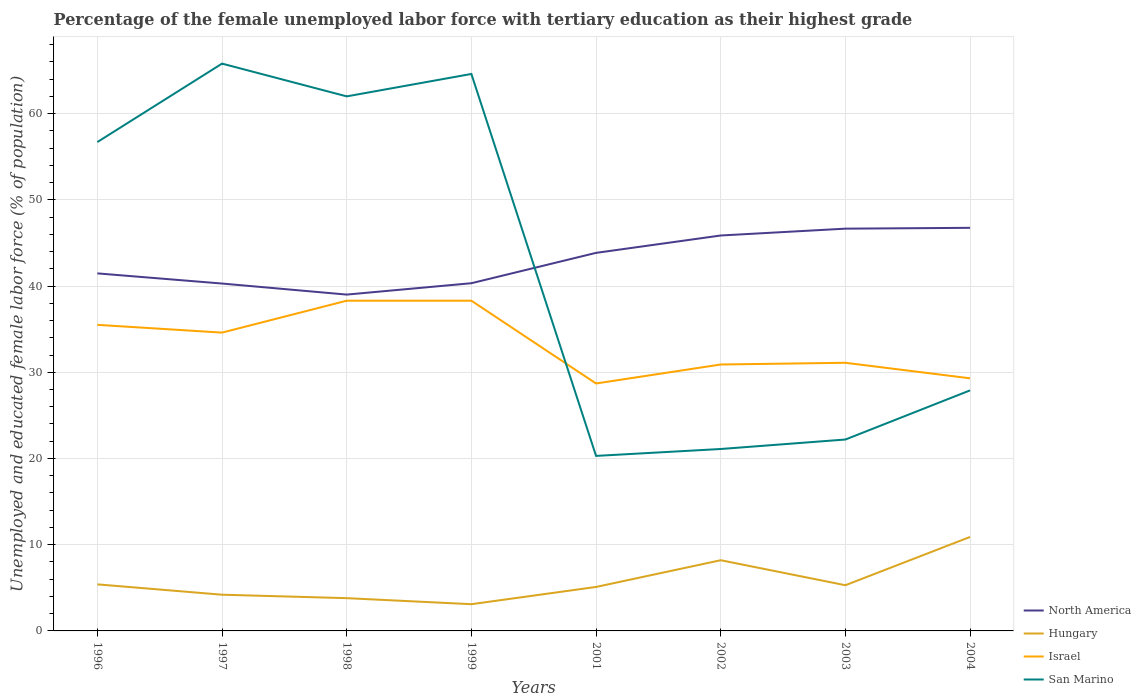Is the number of lines equal to the number of legend labels?
Provide a short and direct response. Yes. Across all years, what is the maximum percentage of the unemployed female labor force with tertiary education in San Marino?
Your answer should be very brief. 20.3. In which year was the percentage of the unemployed female labor force with tertiary education in Israel maximum?
Keep it short and to the point. 2001. What is the total percentage of the unemployed female labor force with tertiary education in San Marino in the graph?
Keep it short and to the point. 1.2. What is the difference between the highest and the second highest percentage of the unemployed female labor force with tertiary education in North America?
Make the answer very short. 7.74. Is the percentage of the unemployed female labor force with tertiary education in San Marino strictly greater than the percentage of the unemployed female labor force with tertiary education in Hungary over the years?
Your answer should be very brief. No. What is the difference between two consecutive major ticks on the Y-axis?
Offer a very short reply. 10. How are the legend labels stacked?
Offer a terse response. Vertical. What is the title of the graph?
Provide a short and direct response. Percentage of the female unemployed labor force with tertiary education as their highest grade. What is the label or title of the X-axis?
Provide a short and direct response. Years. What is the label or title of the Y-axis?
Provide a succinct answer. Unemployed and educated female labor force (% of population). What is the Unemployed and educated female labor force (% of population) in North America in 1996?
Give a very brief answer. 41.47. What is the Unemployed and educated female labor force (% of population) in Hungary in 1996?
Offer a terse response. 5.4. What is the Unemployed and educated female labor force (% of population) of Israel in 1996?
Keep it short and to the point. 35.5. What is the Unemployed and educated female labor force (% of population) in San Marino in 1996?
Provide a succinct answer. 56.7. What is the Unemployed and educated female labor force (% of population) of North America in 1997?
Your answer should be compact. 40.29. What is the Unemployed and educated female labor force (% of population) in Hungary in 1997?
Your answer should be compact. 4.2. What is the Unemployed and educated female labor force (% of population) of Israel in 1997?
Make the answer very short. 34.6. What is the Unemployed and educated female labor force (% of population) of San Marino in 1997?
Your answer should be very brief. 65.8. What is the Unemployed and educated female labor force (% of population) in North America in 1998?
Provide a succinct answer. 39.01. What is the Unemployed and educated female labor force (% of population) in Hungary in 1998?
Provide a short and direct response. 3.8. What is the Unemployed and educated female labor force (% of population) of Israel in 1998?
Your response must be concise. 38.3. What is the Unemployed and educated female labor force (% of population) of North America in 1999?
Keep it short and to the point. 40.33. What is the Unemployed and educated female labor force (% of population) in Hungary in 1999?
Offer a terse response. 3.1. What is the Unemployed and educated female labor force (% of population) in Israel in 1999?
Ensure brevity in your answer.  38.3. What is the Unemployed and educated female labor force (% of population) of San Marino in 1999?
Make the answer very short. 64.6. What is the Unemployed and educated female labor force (% of population) in North America in 2001?
Give a very brief answer. 43.85. What is the Unemployed and educated female labor force (% of population) in Hungary in 2001?
Your answer should be compact. 5.1. What is the Unemployed and educated female labor force (% of population) in Israel in 2001?
Ensure brevity in your answer.  28.7. What is the Unemployed and educated female labor force (% of population) in San Marino in 2001?
Your answer should be very brief. 20.3. What is the Unemployed and educated female labor force (% of population) in North America in 2002?
Provide a short and direct response. 45.86. What is the Unemployed and educated female labor force (% of population) in Hungary in 2002?
Keep it short and to the point. 8.2. What is the Unemployed and educated female labor force (% of population) in Israel in 2002?
Your answer should be compact. 30.9. What is the Unemployed and educated female labor force (% of population) of San Marino in 2002?
Your answer should be very brief. 21.1. What is the Unemployed and educated female labor force (% of population) of North America in 2003?
Offer a terse response. 46.66. What is the Unemployed and educated female labor force (% of population) in Hungary in 2003?
Give a very brief answer. 5.3. What is the Unemployed and educated female labor force (% of population) of Israel in 2003?
Give a very brief answer. 31.1. What is the Unemployed and educated female labor force (% of population) in San Marino in 2003?
Your answer should be very brief. 22.2. What is the Unemployed and educated female labor force (% of population) of North America in 2004?
Ensure brevity in your answer.  46.75. What is the Unemployed and educated female labor force (% of population) in Hungary in 2004?
Offer a terse response. 10.9. What is the Unemployed and educated female labor force (% of population) in Israel in 2004?
Offer a terse response. 29.3. What is the Unemployed and educated female labor force (% of population) of San Marino in 2004?
Offer a terse response. 27.9. Across all years, what is the maximum Unemployed and educated female labor force (% of population) in North America?
Your response must be concise. 46.75. Across all years, what is the maximum Unemployed and educated female labor force (% of population) of Hungary?
Provide a short and direct response. 10.9. Across all years, what is the maximum Unemployed and educated female labor force (% of population) in Israel?
Provide a succinct answer. 38.3. Across all years, what is the maximum Unemployed and educated female labor force (% of population) in San Marino?
Your answer should be compact. 65.8. Across all years, what is the minimum Unemployed and educated female labor force (% of population) in North America?
Make the answer very short. 39.01. Across all years, what is the minimum Unemployed and educated female labor force (% of population) in Hungary?
Your answer should be compact. 3.1. Across all years, what is the minimum Unemployed and educated female labor force (% of population) of Israel?
Provide a short and direct response. 28.7. Across all years, what is the minimum Unemployed and educated female labor force (% of population) of San Marino?
Your answer should be very brief. 20.3. What is the total Unemployed and educated female labor force (% of population) of North America in the graph?
Your response must be concise. 344.22. What is the total Unemployed and educated female labor force (% of population) in Hungary in the graph?
Your response must be concise. 46. What is the total Unemployed and educated female labor force (% of population) in Israel in the graph?
Keep it short and to the point. 266.7. What is the total Unemployed and educated female labor force (% of population) of San Marino in the graph?
Your response must be concise. 340.6. What is the difference between the Unemployed and educated female labor force (% of population) of North America in 1996 and that in 1997?
Give a very brief answer. 1.18. What is the difference between the Unemployed and educated female labor force (% of population) in San Marino in 1996 and that in 1997?
Give a very brief answer. -9.1. What is the difference between the Unemployed and educated female labor force (% of population) of North America in 1996 and that in 1998?
Offer a terse response. 2.46. What is the difference between the Unemployed and educated female labor force (% of population) of Israel in 1996 and that in 1998?
Your response must be concise. -2.8. What is the difference between the Unemployed and educated female labor force (% of population) in North America in 1996 and that in 1999?
Give a very brief answer. 1.14. What is the difference between the Unemployed and educated female labor force (% of population) in Hungary in 1996 and that in 1999?
Your response must be concise. 2.3. What is the difference between the Unemployed and educated female labor force (% of population) of Israel in 1996 and that in 1999?
Offer a terse response. -2.8. What is the difference between the Unemployed and educated female labor force (% of population) in San Marino in 1996 and that in 1999?
Ensure brevity in your answer.  -7.9. What is the difference between the Unemployed and educated female labor force (% of population) of North America in 1996 and that in 2001?
Your response must be concise. -2.38. What is the difference between the Unemployed and educated female labor force (% of population) in Hungary in 1996 and that in 2001?
Provide a succinct answer. 0.3. What is the difference between the Unemployed and educated female labor force (% of population) in Israel in 1996 and that in 2001?
Your answer should be compact. 6.8. What is the difference between the Unemployed and educated female labor force (% of population) of San Marino in 1996 and that in 2001?
Ensure brevity in your answer.  36.4. What is the difference between the Unemployed and educated female labor force (% of population) of North America in 1996 and that in 2002?
Your response must be concise. -4.39. What is the difference between the Unemployed and educated female labor force (% of population) in Hungary in 1996 and that in 2002?
Offer a very short reply. -2.8. What is the difference between the Unemployed and educated female labor force (% of population) of San Marino in 1996 and that in 2002?
Offer a very short reply. 35.6. What is the difference between the Unemployed and educated female labor force (% of population) of North America in 1996 and that in 2003?
Make the answer very short. -5.19. What is the difference between the Unemployed and educated female labor force (% of population) in Hungary in 1996 and that in 2003?
Your response must be concise. 0.1. What is the difference between the Unemployed and educated female labor force (% of population) of San Marino in 1996 and that in 2003?
Provide a short and direct response. 34.5. What is the difference between the Unemployed and educated female labor force (% of population) of North America in 1996 and that in 2004?
Ensure brevity in your answer.  -5.28. What is the difference between the Unemployed and educated female labor force (% of population) in Israel in 1996 and that in 2004?
Your answer should be compact. 6.2. What is the difference between the Unemployed and educated female labor force (% of population) in San Marino in 1996 and that in 2004?
Give a very brief answer. 28.8. What is the difference between the Unemployed and educated female labor force (% of population) in North America in 1997 and that in 1998?
Your answer should be compact. 1.28. What is the difference between the Unemployed and educated female labor force (% of population) of Israel in 1997 and that in 1998?
Ensure brevity in your answer.  -3.7. What is the difference between the Unemployed and educated female labor force (% of population) of San Marino in 1997 and that in 1998?
Offer a terse response. 3.8. What is the difference between the Unemployed and educated female labor force (% of population) in North America in 1997 and that in 1999?
Provide a short and direct response. -0.04. What is the difference between the Unemployed and educated female labor force (% of population) in Hungary in 1997 and that in 1999?
Offer a terse response. 1.1. What is the difference between the Unemployed and educated female labor force (% of population) in San Marino in 1997 and that in 1999?
Ensure brevity in your answer.  1.2. What is the difference between the Unemployed and educated female labor force (% of population) in North America in 1997 and that in 2001?
Provide a short and direct response. -3.56. What is the difference between the Unemployed and educated female labor force (% of population) of Hungary in 1997 and that in 2001?
Give a very brief answer. -0.9. What is the difference between the Unemployed and educated female labor force (% of population) of San Marino in 1997 and that in 2001?
Offer a terse response. 45.5. What is the difference between the Unemployed and educated female labor force (% of population) in North America in 1997 and that in 2002?
Your answer should be compact. -5.57. What is the difference between the Unemployed and educated female labor force (% of population) in Hungary in 1997 and that in 2002?
Give a very brief answer. -4. What is the difference between the Unemployed and educated female labor force (% of population) in Israel in 1997 and that in 2002?
Make the answer very short. 3.7. What is the difference between the Unemployed and educated female labor force (% of population) of San Marino in 1997 and that in 2002?
Your response must be concise. 44.7. What is the difference between the Unemployed and educated female labor force (% of population) in North America in 1997 and that in 2003?
Make the answer very short. -6.37. What is the difference between the Unemployed and educated female labor force (% of population) in San Marino in 1997 and that in 2003?
Offer a terse response. 43.6. What is the difference between the Unemployed and educated female labor force (% of population) in North America in 1997 and that in 2004?
Give a very brief answer. -6.46. What is the difference between the Unemployed and educated female labor force (% of population) in San Marino in 1997 and that in 2004?
Your response must be concise. 37.9. What is the difference between the Unemployed and educated female labor force (% of population) in North America in 1998 and that in 1999?
Give a very brief answer. -1.32. What is the difference between the Unemployed and educated female labor force (% of population) in San Marino in 1998 and that in 1999?
Provide a succinct answer. -2.6. What is the difference between the Unemployed and educated female labor force (% of population) in North America in 1998 and that in 2001?
Provide a succinct answer. -4.84. What is the difference between the Unemployed and educated female labor force (% of population) of Israel in 1998 and that in 2001?
Offer a terse response. 9.6. What is the difference between the Unemployed and educated female labor force (% of population) in San Marino in 1998 and that in 2001?
Keep it short and to the point. 41.7. What is the difference between the Unemployed and educated female labor force (% of population) of North America in 1998 and that in 2002?
Offer a very short reply. -6.85. What is the difference between the Unemployed and educated female labor force (% of population) in Hungary in 1998 and that in 2002?
Ensure brevity in your answer.  -4.4. What is the difference between the Unemployed and educated female labor force (% of population) of Israel in 1998 and that in 2002?
Offer a very short reply. 7.4. What is the difference between the Unemployed and educated female labor force (% of population) in San Marino in 1998 and that in 2002?
Your answer should be compact. 40.9. What is the difference between the Unemployed and educated female labor force (% of population) in North America in 1998 and that in 2003?
Keep it short and to the point. -7.65. What is the difference between the Unemployed and educated female labor force (% of population) of Israel in 1998 and that in 2003?
Offer a terse response. 7.2. What is the difference between the Unemployed and educated female labor force (% of population) of San Marino in 1998 and that in 2003?
Offer a very short reply. 39.8. What is the difference between the Unemployed and educated female labor force (% of population) of North America in 1998 and that in 2004?
Your answer should be compact. -7.74. What is the difference between the Unemployed and educated female labor force (% of population) in Israel in 1998 and that in 2004?
Offer a terse response. 9. What is the difference between the Unemployed and educated female labor force (% of population) in San Marino in 1998 and that in 2004?
Your response must be concise. 34.1. What is the difference between the Unemployed and educated female labor force (% of population) of North America in 1999 and that in 2001?
Ensure brevity in your answer.  -3.52. What is the difference between the Unemployed and educated female labor force (% of population) in Israel in 1999 and that in 2001?
Provide a succinct answer. 9.6. What is the difference between the Unemployed and educated female labor force (% of population) in San Marino in 1999 and that in 2001?
Give a very brief answer. 44.3. What is the difference between the Unemployed and educated female labor force (% of population) of North America in 1999 and that in 2002?
Offer a very short reply. -5.54. What is the difference between the Unemployed and educated female labor force (% of population) in Israel in 1999 and that in 2002?
Give a very brief answer. 7.4. What is the difference between the Unemployed and educated female labor force (% of population) in San Marino in 1999 and that in 2002?
Offer a very short reply. 43.5. What is the difference between the Unemployed and educated female labor force (% of population) of North America in 1999 and that in 2003?
Provide a short and direct response. -6.33. What is the difference between the Unemployed and educated female labor force (% of population) of Hungary in 1999 and that in 2003?
Keep it short and to the point. -2.2. What is the difference between the Unemployed and educated female labor force (% of population) of Israel in 1999 and that in 2003?
Your answer should be compact. 7.2. What is the difference between the Unemployed and educated female labor force (% of population) of San Marino in 1999 and that in 2003?
Provide a succinct answer. 42.4. What is the difference between the Unemployed and educated female labor force (% of population) of North America in 1999 and that in 2004?
Your answer should be very brief. -6.43. What is the difference between the Unemployed and educated female labor force (% of population) in Hungary in 1999 and that in 2004?
Give a very brief answer. -7.8. What is the difference between the Unemployed and educated female labor force (% of population) in San Marino in 1999 and that in 2004?
Your answer should be very brief. 36.7. What is the difference between the Unemployed and educated female labor force (% of population) in North America in 2001 and that in 2002?
Offer a terse response. -2.01. What is the difference between the Unemployed and educated female labor force (% of population) of Hungary in 2001 and that in 2002?
Your response must be concise. -3.1. What is the difference between the Unemployed and educated female labor force (% of population) in San Marino in 2001 and that in 2002?
Offer a very short reply. -0.8. What is the difference between the Unemployed and educated female labor force (% of population) in North America in 2001 and that in 2003?
Make the answer very short. -2.81. What is the difference between the Unemployed and educated female labor force (% of population) in Israel in 2001 and that in 2003?
Ensure brevity in your answer.  -2.4. What is the difference between the Unemployed and educated female labor force (% of population) in San Marino in 2001 and that in 2003?
Keep it short and to the point. -1.9. What is the difference between the Unemployed and educated female labor force (% of population) in North America in 2001 and that in 2004?
Your response must be concise. -2.9. What is the difference between the Unemployed and educated female labor force (% of population) of Hungary in 2001 and that in 2004?
Offer a very short reply. -5.8. What is the difference between the Unemployed and educated female labor force (% of population) of North America in 2002 and that in 2003?
Your answer should be very brief. -0.79. What is the difference between the Unemployed and educated female labor force (% of population) in Hungary in 2002 and that in 2003?
Offer a terse response. 2.9. What is the difference between the Unemployed and educated female labor force (% of population) in Israel in 2002 and that in 2003?
Offer a very short reply. -0.2. What is the difference between the Unemployed and educated female labor force (% of population) in San Marino in 2002 and that in 2003?
Your response must be concise. -1.1. What is the difference between the Unemployed and educated female labor force (% of population) in North America in 2002 and that in 2004?
Make the answer very short. -0.89. What is the difference between the Unemployed and educated female labor force (% of population) in Israel in 2002 and that in 2004?
Offer a terse response. 1.6. What is the difference between the Unemployed and educated female labor force (% of population) in San Marino in 2002 and that in 2004?
Ensure brevity in your answer.  -6.8. What is the difference between the Unemployed and educated female labor force (% of population) in North America in 2003 and that in 2004?
Provide a short and direct response. -0.1. What is the difference between the Unemployed and educated female labor force (% of population) of Hungary in 2003 and that in 2004?
Your answer should be very brief. -5.6. What is the difference between the Unemployed and educated female labor force (% of population) in Israel in 2003 and that in 2004?
Make the answer very short. 1.8. What is the difference between the Unemployed and educated female labor force (% of population) in San Marino in 2003 and that in 2004?
Ensure brevity in your answer.  -5.7. What is the difference between the Unemployed and educated female labor force (% of population) in North America in 1996 and the Unemployed and educated female labor force (% of population) in Hungary in 1997?
Keep it short and to the point. 37.27. What is the difference between the Unemployed and educated female labor force (% of population) of North America in 1996 and the Unemployed and educated female labor force (% of population) of Israel in 1997?
Ensure brevity in your answer.  6.87. What is the difference between the Unemployed and educated female labor force (% of population) of North America in 1996 and the Unemployed and educated female labor force (% of population) of San Marino in 1997?
Your response must be concise. -24.33. What is the difference between the Unemployed and educated female labor force (% of population) in Hungary in 1996 and the Unemployed and educated female labor force (% of population) in Israel in 1997?
Provide a succinct answer. -29.2. What is the difference between the Unemployed and educated female labor force (% of population) in Hungary in 1996 and the Unemployed and educated female labor force (% of population) in San Marino in 1997?
Give a very brief answer. -60.4. What is the difference between the Unemployed and educated female labor force (% of population) of Israel in 1996 and the Unemployed and educated female labor force (% of population) of San Marino in 1997?
Make the answer very short. -30.3. What is the difference between the Unemployed and educated female labor force (% of population) of North America in 1996 and the Unemployed and educated female labor force (% of population) of Hungary in 1998?
Offer a terse response. 37.67. What is the difference between the Unemployed and educated female labor force (% of population) in North America in 1996 and the Unemployed and educated female labor force (% of population) in Israel in 1998?
Provide a succinct answer. 3.17. What is the difference between the Unemployed and educated female labor force (% of population) of North America in 1996 and the Unemployed and educated female labor force (% of population) of San Marino in 1998?
Offer a very short reply. -20.53. What is the difference between the Unemployed and educated female labor force (% of population) in Hungary in 1996 and the Unemployed and educated female labor force (% of population) in Israel in 1998?
Give a very brief answer. -32.9. What is the difference between the Unemployed and educated female labor force (% of population) in Hungary in 1996 and the Unemployed and educated female labor force (% of population) in San Marino in 1998?
Make the answer very short. -56.6. What is the difference between the Unemployed and educated female labor force (% of population) in Israel in 1996 and the Unemployed and educated female labor force (% of population) in San Marino in 1998?
Your answer should be compact. -26.5. What is the difference between the Unemployed and educated female labor force (% of population) in North America in 1996 and the Unemployed and educated female labor force (% of population) in Hungary in 1999?
Offer a very short reply. 38.37. What is the difference between the Unemployed and educated female labor force (% of population) in North America in 1996 and the Unemployed and educated female labor force (% of population) in Israel in 1999?
Your answer should be compact. 3.17. What is the difference between the Unemployed and educated female labor force (% of population) in North America in 1996 and the Unemployed and educated female labor force (% of population) in San Marino in 1999?
Offer a terse response. -23.13. What is the difference between the Unemployed and educated female labor force (% of population) of Hungary in 1996 and the Unemployed and educated female labor force (% of population) of Israel in 1999?
Provide a succinct answer. -32.9. What is the difference between the Unemployed and educated female labor force (% of population) in Hungary in 1996 and the Unemployed and educated female labor force (% of population) in San Marino in 1999?
Ensure brevity in your answer.  -59.2. What is the difference between the Unemployed and educated female labor force (% of population) of Israel in 1996 and the Unemployed and educated female labor force (% of population) of San Marino in 1999?
Offer a very short reply. -29.1. What is the difference between the Unemployed and educated female labor force (% of population) of North America in 1996 and the Unemployed and educated female labor force (% of population) of Hungary in 2001?
Keep it short and to the point. 36.37. What is the difference between the Unemployed and educated female labor force (% of population) of North America in 1996 and the Unemployed and educated female labor force (% of population) of Israel in 2001?
Offer a very short reply. 12.77. What is the difference between the Unemployed and educated female labor force (% of population) in North America in 1996 and the Unemployed and educated female labor force (% of population) in San Marino in 2001?
Give a very brief answer. 21.17. What is the difference between the Unemployed and educated female labor force (% of population) of Hungary in 1996 and the Unemployed and educated female labor force (% of population) of Israel in 2001?
Offer a terse response. -23.3. What is the difference between the Unemployed and educated female labor force (% of population) in Hungary in 1996 and the Unemployed and educated female labor force (% of population) in San Marino in 2001?
Your answer should be very brief. -14.9. What is the difference between the Unemployed and educated female labor force (% of population) of Israel in 1996 and the Unemployed and educated female labor force (% of population) of San Marino in 2001?
Make the answer very short. 15.2. What is the difference between the Unemployed and educated female labor force (% of population) of North America in 1996 and the Unemployed and educated female labor force (% of population) of Hungary in 2002?
Offer a terse response. 33.27. What is the difference between the Unemployed and educated female labor force (% of population) in North America in 1996 and the Unemployed and educated female labor force (% of population) in Israel in 2002?
Your answer should be very brief. 10.57. What is the difference between the Unemployed and educated female labor force (% of population) in North America in 1996 and the Unemployed and educated female labor force (% of population) in San Marino in 2002?
Keep it short and to the point. 20.37. What is the difference between the Unemployed and educated female labor force (% of population) in Hungary in 1996 and the Unemployed and educated female labor force (% of population) in Israel in 2002?
Give a very brief answer. -25.5. What is the difference between the Unemployed and educated female labor force (% of population) of Hungary in 1996 and the Unemployed and educated female labor force (% of population) of San Marino in 2002?
Offer a terse response. -15.7. What is the difference between the Unemployed and educated female labor force (% of population) of Israel in 1996 and the Unemployed and educated female labor force (% of population) of San Marino in 2002?
Provide a succinct answer. 14.4. What is the difference between the Unemployed and educated female labor force (% of population) of North America in 1996 and the Unemployed and educated female labor force (% of population) of Hungary in 2003?
Give a very brief answer. 36.17. What is the difference between the Unemployed and educated female labor force (% of population) of North America in 1996 and the Unemployed and educated female labor force (% of population) of Israel in 2003?
Your answer should be compact. 10.37. What is the difference between the Unemployed and educated female labor force (% of population) of North America in 1996 and the Unemployed and educated female labor force (% of population) of San Marino in 2003?
Offer a terse response. 19.27. What is the difference between the Unemployed and educated female labor force (% of population) in Hungary in 1996 and the Unemployed and educated female labor force (% of population) in Israel in 2003?
Ensure brevity in your answer.  -25.7. What is the difference between the Unemployed and educated female labor force (% of population) of Hungary in 1996 and the Unemployed and educated female labor force (% of population) of San Marino in 2003?
Give a very brief answer. -16.8. What is the difference between the Unemployed and educated female labor force (% of population) in North America in 1996 and the Unemployed and educated female labor force (% of population) in Hungary in 2004?
Ensure brevity in your answer.  30.57. What is the difference between the Unemployed and educated female labor force (% of population) of North America in 1996 and the Unemployed and educated female labor force (% of population) of Israel in 2004?
Provide a short and direct response. 12.17. What is the difference between the Unemployed and educated female labor force (% of population) in North America in 1996 and the Unemployed and educated female labor force (% of population) in San Marino in 2004?
Your response must be concise. 13.57. What is the difference between the Unemployed and educated female labor force (% of population) of Hungary in 1996 and the Unemployed and educated female labor force (% of population) of Israel in 2004?
Your response must be concise. -23.9. What is the difference between the Unemployed and educated female labor force (% of population) of Hungary in 1996 and the Unemployed and educated female labor force (% of population) of San Marino in 2004?
Your answer should be very brief. -22.5. What is the difference between the Unemployed and educated female labor force (% of population) in North America in 1997 and the Unemployed and educated female labor force (% of population) in Hungary in 1998?
Provide a short and direct response. 36.49. What is the difference between the Unemployed and educated female labor force (% of population) in North America in 1997 and the Unemployed and educated female labor force (% of population) in Israel in 1998?
Ensure brevity in your answer.  1.99. What is the difference between the Unemployed and educated female labor force (% of population) in North America in 1997 and the Unemployed and educated female labor force (% of population) in San Marino in 1998?
Ensure brevity in your answer.  -21.71. What is the difference between the Unemployed and educated female labor force (% of population) in Hungary in 1997 and the Unemployed and educated female labor force (% of population) in Israel in 1998?
Your answer should be compact. -34.1. What is the difference between the Unemployed and educated female labor force (% of population) of Hungary in 1997 and the Unemployed and educated female labor force (% of population) of San Marino in 1998?
Make the answer very short. -57.8. What is the difference between the Unemployed and educated female labor force (% of population) of Israel in 1997 and the Unemployed and educated female labor force (% of population) of San Marino in 1998?
Your answer should be compact. -27.4. What is the difference between the Unemployed and educated female labor force (% of population) of North America in 1997 and the Unemployed and educated female labor force (% of population) of Hungary in 1999?
Your answer should be compact. 37.19. What is the difference between the Unemployed and educated female labor force (% of population) of North America in 1997 and the Unemployed and educated female labor force (% of population) of Israel in 1999?
Your response must be concise. 1.99. What is the difference between the Unemployed and educated female labor force (% of population) in North America in 1997 and the Unemployed and educated female labor force (% of population) in San Marino in 1999?
Ensure brevity in your answer.  -24.31. What is the difference between the Unemployed and educated female labor force (% of population) of Hungary in 1997 and the Unemployed and educated female labor force (% of population) of Israel in 1999?
Ensure brevity in your answer.  -34.1. What is the difference between the Unemployed and educated female labor force (% of population) in Hungary in 1997 and the Unemployed and educated female labor force (% of population) in San Marino in 1999?
Offer a terse response. -60.4. What is the difference between the Unemployed and educated female labor force (% of population) in Israel in 1997 and the Unemployed and educated female labor force (% of population) in San Marino in 1999?
Offer a very short reply. -30. What is the difference between the Unemployed and educated female labor force (% of population) in North America in 1997 and the Unemployed and educated female labor force (% of population) in Hungary in 2001?
Offer a very short reply. 35.19. What is the difference between the Unemployed and educated female labor force (% of population) of North America in 1997 and the Unemployed and educated female labor force (% of population) of Israel in 2001?
Your response must be concise. 11.59. What is the difference between the Unemployed and educated female labor force (% of population) in North America in 1997 and the Unemployed and educated female labor force (% of population) in San Marino in 2001?
Provide a short and direct response. 19.99. What is the difference between the Unemployed and educated female labor force (% of population) in Hungary in 1997 and the Unemployed and educated female labor force (% of population) in Israel in 2001?
Your answer should be very brief. -24.5. What is the difference between the Unemployed and educated female labor force (% of population) of Hungary in 1997 and the Unemployed and educated female labor force (% of population) of San Marino in 2001?
Your response must be concise. -16.1. What is the difference between the Unemployed and educated female labor force (% of population) of Israel in 1997 and the Unemployed and educated female labor force (% of population) of San Marino in 2001?
Your response must be concise. 14.3. What is the difference between the Unemployed and educated female labor force (% of population) in North America in 1997 and the Unemployed and educated female labor force (% of population) in Hungary in 2002?
Keep it short and to the point. 32.09. What is the difference between the Unemployed and educated female labor force (% of population) in North America in 1997 and the Unemployed and educated female labor force (% of population) in Israel in 2002?
Your answer should be compact. 9.39. What is the difference between the Unemployed and educated female labor force (% of population) of North America in 1997 and the Unemployed and educated female labor force (% of population) of San Marino in 2002?
Your answer should be very brief. 19.19. What is the difference between the Unemployed and educated female labor force (% of population) of Hungary in 1997 and the Unemployed and educated female labor force (% of population) of Israel in 2002?
Offer a terse response. -26.7. What is the difference between the Unemployed and educated female labor force (% of population) in Hungary in 1997 and the Unemployed and educated female labor force (% of population) in San Marino in 2002?
Your response must be concise. -16.9. What is the difference between the Unemployed and educated female labor force (% of population) of North America in 1997 and the Unemployed and educated female labor force (% of population) of Hungary in 2003?
Make the answer very short. 34.99. What is the difference between the Unemployed and educated female labor force (% of population) of North America in 1997 and the Unemployed and educated female labor force (% of population) of Israel in 2003?
Your answer should be compact. 9.19. What is the difference between the Unemployed and educated female labor force (% of population) in North America in 1997 and the Unemployed and educated female labor force (% of population) in San Marino in 2003?
Offer a very short reply. 18.09. What is the difference between the Unemployed and educated female labor force (% of population) in Hungary in 1997 and the Unemployed and educated female labor force (% of population) in Israel in 2003?
Make the answer very short. -26.9. What is the difference between the Unemployed and educated female labor force (% of population) in Hungary in 1997 and the Unemployed and educated female labor force (% of population) in San Marino in 2003?
Your response must be concise. -18. What is the difference between the Unemployed and educated female labor force (% of population) in Israel in 1997 and the Unemployed and educated female labor force (% of population) in San Marino in 2003?
Keep it short and to the point. 12.4. What is the difference between the Unemployed and educated female labor force (% of population) of North America in 1997 and the Unemployed and educated female labor force (% of population) of Hungary in 2004?
Make the answer very short. 29.39. What is the difference between the Unemployed and educated female labor force (% of population) of North America in 1997 and the Unemployed and educated female labor force (% of population) of Israel in 2004?
Give a very brief answer. 10.99. What is the difference between the Unemployed and educated female labor force (% of population) of North America in 1997 and the Unemployed and educated female labor force (% of population) of San Marino in 2004?
Make the answer very short. 12.39. What is the difference between the Unemployed and educated female labor force (% of population) of Hungary in 1997 and the Unemployed and educated female labor force (% of population) of Israel in 2004?
Offer a terse response. -25.1. What is the difference between the Unemployed and educated female labor force (% of population) in Hungary in 1997 and the Unemployed and educated female labor force (% of population) in San Marino in 2004?
Give a very brief answer. -23.7. What is the difference between the Unemployed and educated female labor force (% of population) of Israel in 1997 and the Unemployed and educated female labor force (% of population) of San Marino in 2004?
Ensure brevity in your answer.  6.7. What is the difference between the Unemployed and educated female labor force (% of population) of North America in 1998 and the Unemployed and educated female labor force (% of population) of Hungary in 1999?
Your answer should be very brief. 35.91. What is the difference between the Unemployed and educated female labor force (% of population) of North America in 1998 and the Unemployed and educated female labor force (% of population) of Israel in 1999?
Your answer should be compact. 0.71. What is the difference between the Unemployed and educated female labor force (% of population) in North America in 1998 and the Unemployed and educated female labor force (% of population) in San Marino in 1999?
Give a very brief answer. -25.59. What is the difference between the Unemployed and educated female labor force (% of population) in Hungary in 1998 and the Unemployed and educated female labor force (% of population) in Israel in 1999?
Ensure brevity in your answer.  -34.5. What is the difference between the Unemployed and educated female labor force (% of population) of Hungary in 1998 and the Unemployed and educated female labor force (% of population) of San Marino in 1999?
Your answer should be very brief. -60.8. What is the difference between the Unemployed and educated female labor force (% of population) of Israel in 1998 and the Unemployed and educated female labor force (% of population) of San Marino in 1999?
Make the answer very short. -26.3. What is the difference between the Unemployed and educated female labor force (% of population) in North America in 1998 and the Unemployed and educated female labor force (% of population) in Hungary in 2001?
Offer a terse response. 33.91. What is the difference between the Unemployed and educated female labor force (% of population) of North America in 1998 and the Unemployed and educated female labor force (% of population) of Israel in 2001?
Ensure brevity in your answer.  10.31. What is the difference between the Unemployed and educated female labor force (% of population) of North America in 1998 and the Unemployed and educated female labor force (% of population) of San Marino in 2001?
Make the answer very short. 18.71. What is the difference between the Unemployed and educated female labor force (% of population) in Hungary in 1998 and the Unemployed and educated female labor force (% of population) in Israel in 2001?
Your answer should be compact. -24.9. What is the difference between the Unemployed and educated female labor force (% of population) in Hungary in 1998 and the Unemployed and educated female labor force (% of population) in San Marino in 2001?
Give a very brief answer. -16.5. What is the difference between the Unemployed and educated female labor force (% of population) of North America in 1998 and the Unemployed and educated female labor force (% of population) of Hungary in 2002?
Offer a terse response. 30.81. What is the difference between the Unemployed and educated female labor force (% of population) in North America in 1998 and the Unemployed and educated female labor force (% of population) in Israel in 2002?
Your answer should be very brief. 8.11. What is the difference between the Unemployed and educated female labor force (% of population) in North America in 1998 and the Unemployed and educated female labor force (% of population) in San Marino in 2002?
Your answer should be compact. 17.91. What is the difference between the Unemployed and educated female labor force (% of population) in Hungary in 1998 and the Unemployed and educated female labor force (% of population) in Israel in 2002?
Keep it short and to the point. -27.1. What is the difference between the Unemployed and educated female labor force (% of population) of Hungary in 1998 and the Unemployed and educated female labor force (% of population) of San Marino in 2002?
Ensure brevity in your answer.  -17.3. What is the difference between the Unemployed and educated female labor force (% of population) of North America in 1998 and the Unemployed and educated female labor force (% of population) of Hungary in 2003?
Offer a very short reply. 33.71. What is the difference between the Unemployed and educated female labor force (% of population) of North America in 1998 and the Unemployed and educated female labor force (% of population) of Israel in 2003?
Your response must be concise. 7.91. What is the difference between the Unemployed and educated female labor force (% of population) in North America in 1998 and the Unemployed and educated female labor force (% of population) in San Marino in 2003?
Your answer should be very brief. 16.81. What is the difference between the Unemployed and educated female labor force (% of population) of Hungary in 1998 and the Unemployed and educated female labor force (% of population) of Israel in 2003?
Give a very brief answer. -27.3. What is the difference between the Unemployed and educated female labor force (% of population) of Hungary in 1998 and the Unemployed and educated female labor force (% of population) of San Marino in 2003?
Keep it short and to the point. -18.4. What is the difference between the Unemployed and educated female labor force (% of population) of North America in 1998 and the Unemployed and educated female labor force (% of population) of Hungary in 2004?
Offer a terse response. 28.11. What is the difference between the Unemployed and educated female labor force (% of population) in North America in 1998 and the Unemployed and educated female labor force (% of population) in Israel in 2004?
Your response must be concise. 9.71. What is the difference between the Unemployed and educated female labor force (% of population) of North America in 1998 and the Unemployed and educated female labor force (% of population) of San Marino in 2004?
Keep it short and to the point. 11.11. What is the difference between the Unemployed and educated female labor force (% of population) of Hungary in 1998 and the Unemployed and educated female labor force (% of population) of Israel in 2004?
Your answer should be compact. -25.5. What is the difference between the Unemployed and educated female labor force (% of population) of Hungary in 1998 and the Unemployed and educated female labor force (% of population) of San Marino in 2004?
Give a very brief answer. -24.1. What is the difference between the Unemployed and educated female labor force (% of population) in Israel in 1998 and the Unemployed and educated female labor force (% of population) in San Marino in 2004?
Provide a succinct answer. 10.4. What is the difference between the Unemployed and educated female labor force (% of population) in North America in 1999 and the Unemployed and educated female labor force (% of population) in Hungary in 2001?
Your response must be concise. 35.23. What is the difference between the Unemployed and educated female labor force (% of population) of North America in 1999 and the Unemployed and educated female labor force (% of population) of Israel in 2001?
Make the answer very short. 11.63. What is the difference between the Unemployed and educated female labor force (% of population) in North America in 1999 and the Unemployed and educated female labor force (% of population) in San Marino in 2001?
Offer a very short reply. 20.03. What is the difference between the Unemployed and educated female labor force (% of population) of Hungary in 1999 and the Unemployed and educated female labor force (% of population) of Israel in 2001?
Your response must be concise. -25.6. What is the difference between the Unemployed and educated female labor force (% of population) of Hungary in 1999 and the Unemployed and educated female labor force (% of population) of San Marino in 2001?
Offer a terse response. -17.2. What is the difference between the Unemployed and educated female labor force (% of population) in North America in 1999 and the Unemployed and educated female labor force (% of population) in Hungary in 2002?
Keep it short and to the point. 32.13. What is the difference between the Unemployed and educated female labor force (% of population) of North America in 1999 and the Unemployed and educated female labor force (% of population) of Israel in 2002?
Offer a very short reply. 9.43. What is the difference between the Unemployed and educated female labor force (% of population) in North America in 1999 and the Unemployed and educated female labor force (% of population) in San Marino in 2002?
Provide a short and direct response. 19.23. What is the difference between the Unemployed and educated female labor force (% of population) of Hungary in 1999 and the Unemployed and educated female labor force (% of population) of Israel in 2002?
Provide a short and direct response. -27.8. What is the difference between the Unemployed and educated female labor force (% of population) in Hungary in 1999 and the Unemployed and educated female labor force (% of population) in San Marino in 2002?
Give a very brief answer. -18. What is the difference between the Unemployed and educated female labor force (% of population) of Israel in 1999 and the Unemployed and educated female labor force (% of population) of San Marino in 2002?
Offer a terse response. 17.2. What is the difference between the Unemployed and educated female labor force (% of population) in North America in 1999 and the Unemployed and educated female labor force (% of population) in Hungary in 2003?
Your answer should be compact. 35.03. What is the difference between the Unemployed and educated female labor force (% of population) in North America in 1999 and the Unemployed and educated female labor force (% of population) in Israel in 2003?
Offer a very short reply. 9.23. What is the difference between the Unemployed and educated female labor force (% of population) in North America in 1999 and the Unemployed and educated female labor force (% of population) in San Marino in 2003?
Ensure brevity in your answer.  18.13. What is the difference between the Unemployed and educated female labor force (% of population) of Hungary in 1999 and the Unemployed and educated female labor force (% of population) of Israel in 2003?
Make the answer very short. -28. What is the difference between the Unemployed and educated female labor force (% of population) in Hungary in 1999 and the Unemployed and educated female labor force (% of population) in San Marino in 2003?
Your response must be concise. -19.1. What is the difference between the Unemployed and educated female labor force (% of population) in Israel in 1999 and the Unemployed and educated female labor force (% of population) in San Marino in 2003?
Give a very brief answer. 16.1. What is the difference between the Unemployed and educated female labor force (% of population) in North America in 1999 and the Unemployed and educated female labor force (% of population) in Hungary in 2004?
Your answer should be very brief. 29.43. What is the difference between the Unemployed and educated female labor force (% of population) of North America in 1999 and the Unemployed and educated female labor force (% of population) of Israel in 2004?
Your answer should be very brief. 11.03. What is the difference between the Unemployed and educated female labor force (% of population) of North America in 1999 and the Unemployed and educated female labor force (% of population) of San Marino in 2004?
Provide a short and direct response. 12.43. What is the difference between the Unemployed and educated female labor force (% of population) in Hungary in 1999 and the Unemployed and educated female labor force (% of population) in Israel in 2004?
Offer a terse response. -26.2. What is the difference between the Unemployed and educated female labor force (% of population) in Hungary in 1999 and the Unemployed and educated female labor force (% of population) in San Marino in 2004?
Ensure brevity in your answer.  -24.8. What is the difference between the Unemployed and educated female labor force (% of population) of North America in 2001 and the Unemployed and educated female labor force (% of population) of Hungary in 2002?
Your response must be concise. 35.65. What is the difference between the Unemployed and educated female labor force (% of population) in North America in 2001 and the Unemployed and educated female labor force (% of population) in Israel in 2002?
Your answer should be very brief. 12.95. What is the difference between the Unemployed and educated female labor force (% of population) in North America in 2001 and the Unemployed and educated female labor force (% of population) in San Marino in 2002?
Keep it short and to the point. 22.75. What is the difference between the Unemployed and educated female labor force (% of population) in Hungary in 2001 and the Unemployed and educated female labor force (% of population) in Israel in 2002?
Your response must be concise. -25.8. What is the difference between the Unemployed and educated female labor force (% of population) of Israel in 2001 and the Unemployed and educated female labor force (% of population) of San Marino in 2002?
Make the answer very short. 7.6. What is the difference between the Unemployed and educated female labor force (% of population) in North America in 2001 and the Unemployed and educated female labor force (% of population) in Hungary in 2003?
Provide a succinct answer. 38.55. What is the difference between the Unemployed and educated female labor force (% of population) of North America in 2001 and the Unemployed and educated female labor force (% of population) of Israel in 2003?
Ensure brevity in your answer.  12.75. What is the difference between the Unemployed and educated female labor force (% of population) in North America in 2001 and the Unemployed and educated female labor force (% of population) in San Marino in 2003?
Your answer should be compact. 21.65. What is the difference between the Unemployed and educated female labor force (% of population) in Hungary in 2001 and the Unemployed and educated female labor force (% of population) in Israel in 2003?
Offer a terse response. -26. What is the difference between the Unemployed and educated female labor force (% of population) in Hungary in 2001 and the Unemployed and educated female labor force (% of population) in San Marino in 2003?
Offer a terse response. -17.1. What is the difference between the Unemployed and educated female labor force (% of population) of North America in 2001 and the Unemployed and educated female labor force (% of population) of Hungary in 2004?
Your answer should be compact. 32.95. What is the difference between the Unemployed and educated female labor force (% of population) of North America in 2001 and the Unemployed and educated female labor force (% of population) of Israel in 2004?
Make the answer very short. 14.55. What is the difference between the Unemployed and educated female labor force (% of population) of North America in 2001 and the Unemployed and educated female labor force (% of population) of San Marino in 2004?
Give a very brief answer. 15.95. What is the difference between the Unemployed and educated female labor force (% of population) in Hungary in 2001 and the Unemployed and educated female labor force (% of population) in Israel in 2004?
Offer a very short reply. -24.2. What is the difference between the Unemployed and educated female labor force (% of population) in Hungary in 2001 and the Unemployed and educated female labor force (% of population) in San Marino in 2004?
Your answer should be compact. -22.8. What is the difference between the Unemployed and educated female labor force (% of population) of North America in 2002 and the Unemployed and educated female labor force (% of population) of Hungary in 2003?
Your response must be concise. 40.56. What is the difference between the Unemployed and educated female labor force (% of population) of North America in 2002 and the Unemployed and educated female labor force (% of population) of Israel in 2003?
Ensure brevity in your answer.  14.76. What is the difference between the Unemployed and educated female labor force (% of population) in North America in 2002 and the Unemployed and educated female labor force (% of population) in San Marino in 2003?
Provide a short and direct response. 23.66. What is the difference between the Unemployed and educated female labor force (% of population) of Hungary in 2002 and the Unemployed and educated female labor force (% of population) of Israel in 2003?
Provide a short and direct response. -22.9. What is the difference between the Unemployed and educated female labor force (% of population) of Hungary in 2002 and the Unemployed and educated female labor force (% of population) of San Marino in 2003?
Your answer should be compact. -14. What is the difference between the Unemployed and educated female labor force (% of population) in Israel in 2002 and the Unemployed and educated female labor force (% of population) in San Marino in 2003?
Keep it short and to the point. 8.7. What is the difference between the Unemployed and educated female labor force (% of population) in North America in 2002 and the Unemployed and educated female labor force (% of population) in Hungary in 2004?
Your answer should be compact. 34.96. What is the difference between the Unemployed and educated female labor force (% of population) of North America in 2002 and the Unemployed and educated female labor force (% of population) of Israel in 2004?
Your answer should be very brief. 16.56. What is the difference between the Unemployed and educated female labor force (% of population) of North America in 2002 and the Unemployed and educated female labor force (% of population) of San Marino in 2004?
Offer a very short reply. 17.96. What is the difference between the Unemployed and educated female labor force (% of population) in Hungary in 2002 and the Unemployed and educated female labor force (% of population) in Israel in 2004?
Make the answer very short. -21.1. What is the difference between the Unemployed and educated female labor force (% of population) of Hungary in 2002 and the Unemployed and educated female labor force (% of population) of San Marino in 2004?
Make the answer very short. -19.7. What is the difference between the Unemployed and educated female labor force (% of population) in Israel in 2002 and the Unemployed and educated female labor force (% of population) in San Marino in 2004?
Provide a succinct answer. 3. What is the difference between the Unemployed and educated female labor force (% of population) in North America in 2003 and the Unemployed and educated female labor force (% of population) in Hungary in 2004?
Keep it short and to the point. 35.76. What is the difference between the Unemployed and educated female labor force (% of population) of North America in 2003 and the Unemployed and educated female labor force (% of population) of Israel in 2004?
Your answer should be very brief. 17.36. What is the difference between the Unemployed and educated female labor force (% of population) in North America in 2003 and the Unemployed and educated female labor force (% of population) in San Marino in 2004?
Give a very brief answer. 18.76. What is the difference between the Unemployed and educated female labor force (% of population) of Hungary in 2003 and the Unemployed and educated female labor force (% of population) of San Marino in 2004?
Your response must be concise. -22.6. What is the difference between the Unemployed and educated female labor force (% of population) in Israel in 2003 and the Unemployed and educated female labor force (% of population) in San Marino in 2004?
Ensure brevity in your answer.  3.2. What is the average Unemployed and educated female labor force (% of population) of North America per year?
Keep it short and to the point. 43.03. What is the average Unemployed and educated female labor force (% of population) of Hungary per year?
Provide a succinct answer. 5.75. What is the average Unemployed and educated female labor force (% of population) in Israel per year?
Provide a succinct answer. 33.34. What is the average Unemployed and educated female labor force (% of population) of San Marino per year?
Your answer should be very brief. 42.58. In the year 1996, what is the difference between the Unemployed and educated female labor force (% of population) in North America and Unemployed and educated female labor force (% of population) in Hungary?
Make the answer very short. 36.07. In the year 1996, what is the difference between the Unemployed and educated female labor force (% of population) in North America and Unemployed and educated female labor force (% of population) in Israel?
Your answer should be compact. 5.97. In the year 1996, what is the difference between the Unemployed and educated female labor force (% of population) in North America and Unemployed and educated female labor force (% of population) in San Marino?
Ensure brevity in your answer.  -15.23. In the year 1996, what is the difference between the Unemployed and educated female labor force (% of population) in Hungary and Unemployed and educated female labor force (% of population) in Israel?
Your response must be concise. -30.1. In the year 1996, what is the difference between the Unemployed and educated female labor force (% of population) of Hungary and Unemployed and educated female labor force (% of population) of San Marino?
Make the answer very short. -51.3. In the year 1996, what is the difference between the Unemployed and educated female labor force (% of population) in Israel and Unemployed and educated female labor force (% of population) in San Marino?
Your answer should be very brief. -21.2. In the year 1997, what is the difference between the Unemployed and educated female labor force (% of population) of North America and Unemployed and educated female labor force (% of population) of Hungary?
Provide a short and direct response. 36.09. In the year 1997, what is the difference between the Unemployed and educated female labor force (% of population) of North America and Unemployed and educated female labor force (% of population) of Israel?
Provide a succinct answer. 5.69. In the year 1997, what is the difference between the Unemployed and educated female labor force (% of population) of North America and Unemployed and educated female labor force (% of population) of San Marino?
Your answer should be very brief. -25.51. In the year 1997, what is the difference between the Unemployed and educated female labor force (% of population) in Hungary and Unemployed and educated female labor force (% of population) in Israel?
Provide a short and direct response. -30.4. In the year 1997, what is the difference between the Unemployed and educated female labor force (% of population) of Hungary and Unemployed and educated female labor force (% of population) of San Marino?
Your answer should be compact. -61.6. In the year 1997, what is the difference between the Unemployed and educated female labor force (% of population) in Israel and Unemployed and educated female labor force (% of population) in San Marino?
Provide a succinct answer. -31.2. In the year 1998, what is the difference between the Unemployed and educated female labor force (% of population) in North America and Unemployed and educated female labor force (% of population) in Hungary?
Keep it short and to the point. 35.21. In the year 1998, what is the difference between the Unemployed and educated female labor force (% of population) in North America and Unemployed and educated female labor force (% of population) in Israel?
Make the answer very short. 0.71. In the year 1998, what is the difference between the Unemployed and educated female labor force (% of population) in North America and Unemployed and educated female labor force (% of population) in San Marino?
Give a very brief answer. -22.99. In the year 1998, what is the difference between the Unemployed and educated female labor force (% of population) in Hungary and Unemployed and educated female labor force (% of population) in Israel?
Offer a very short reply. -34.5. In the year 1998, what is the difference between the Unemployed and educated female labor force (% of population) in Hungary and Unemployed and educated female labor force (% of population) in San Marino?
Give a very brief answer. -58.2. In the year 1998, what is the difference between the Unemployed and educated female labor force (% of population) in Israel and Unemployed and educated female labor force (% of population) in San Marino?
Your response must be concise. -23.7. In the year 1999, what is the difference between the Unemployed and educated female labor force (% of population) of North America and Unemployed and educated female labor force (% of population) of Hungary?
Ensure brevity in your answer.  37.23. In the year 1999, what is the difference between the Unemployed and educated female labor force (% of population) in North America and Unemployed and educated female labor force (% of population) in Israel?
Keep it short and to the point. 2.03. In the year 1999, what is the difference between the Unemployed and educated female labor force (% of population) of North America and Unemployed and educated female labor force (% of population) of San Marino?
Ensure brevity in your answer.  -24.27. In the year 1999, what is the difference between the Unemployed and educated female labor force (% of population) of Hungary and Unemployed and educated female labor force (% of population) of Israel?
Keep it short and to the point. -35.2. In the year 1999, what is the difference between the Unemployed and educated female labor force (% of population) of Hungary and Unemployed and educated female labor force (% of population) of San Marino?
Provide a short and direct response. -61.5. In the year 1999, what is the difference between the Unemployed and educated female labor force (% of population) in Israel and Unemployed and educated female labor force (% of population) in San Marino?
Offer a terse response. -26.3. In the year 2001, what is the difference between the Unemployed and educated female labor force (% of population) of North America and Unemployed and educated female labor force (% of population) of Hungary?
Offer a terse response. 38.75. In the year 2001, what is the difference between the Unemployed and educated female labor force (% of population) of North America and Unemployed and educated female labor force (% of population) of Israel?
Offer a very short reply. 15.15. In the year 2001, what is the difference between the Unemployed and educated female labor force (% of population) of North America and Unemployed and educated female labor force (% of population) of San Marino?
Offer a very short reply. 23.55. In the year 2001, what is the difference between the Unemployed and educated female labor force (% of population) in Hungary and Unemployed and educated female labor force (% of population) in Israel?
Make the answer very short. -23.6. In the year 2001, what is the difference between the Unemployed and educated female labor force (% of population) in Hungary and Unemployed and educated female labor force (% of population) in San Marino?
Offer a terse response. -15.2. In the year 2001, what is the difference between the Unemployed and educated female labor force (% of population) of Israel and Unemployed and educated female labor force (% of population) of San Marino?
Provide a short and direct response. 8.4. In the year 2002, what is the difference between the Unemployed and educated female labor force (% of population) of North America and Unemployed and educated female labor force (% of population) of Hungary?
Your answer should be very brief. 37.66. In the year 2002, what is the difference between the Unemployed and educated female labor force (% of population) in North America and Unemployed and educated female labor force (% of population) in Israel?
Your response must be concise. 14.96. In the year 2002, what is the difference between the Unemployed and educated female labor force (% of population) of North America and Unemployed and educated female labor force (% of population) of San Marino?
Ensure brevity in your answer.  24.76. In the year 2002, what is the difference between the Unemployed and educated female labor force (% of population) of Hungary and Unemployed and educated female labor force (% of population) of Israel?
Your response must be concise. -22.7. In the year 2003, what is the difference between the Unemployed and educated female labor force (% of population) of North America and Unemployed and educated female labor force (% of population) of Hungary?
Provide a short and direct response. 41.36. In the year 2003, what is the difference between the Unemployed and educated female labor force (% of population) in North America and Unemployed and educated female labor force (% of population) in Israel?
Provide a succinct answer. 15.56. In the year 2003, what is the difference between the Unemployed and educated female labor force (% of population) in North America and Unemployed and educated female labor force (% of population) in San Marino?
Ensure brevity in your answer.  24.46. In the year 2003, what is the difference between the Unemployed and educated female labor force (% of population) in Hungary and Unemployed and educated female labor force (% of population) in Israel?
Make the answer very short. -25.8. In the year 2003, what is the difference between the Unemployed and educated female labor force (% of population) in Hungary and Unemployed and educated female labor force (% of population) in San Marino?
Give a very brief answer. -16.9. In the year 2003, what is the difference between the Unemployed and educated female labor force (% of population) in Israel and Unemployed and educated female labor force (% of population) in San Marino?
Your response must be concise. 8.9. In the year 2004, what is the difference between the Unemployed and educated female labor force (% of population) in North America and Unemployed and educated female labor force (% of population) in Hungary?
Your answer should be compact. 35.85. In the year 2004, what is the difference between the Unemployed and educated female labor force (% of population) of North America and Unemployed and educated female labor force (% of population) of Israel?
Give a very brief answer. 17.45. In the year 2004, what is the difference between the Unemployed and educated female labor force (% of population) in North America and Unemployed and educated female labor force (% of population) in San Marino?
Provide a short and direct response. 18.85. In the year 2004, what is the difference between the Unemployed and educated female labor force (% of population) of Hungary and Unemployed and educated female labor force (% of population) of Israel?
Give a very brief answer. -18.4. In the year 2004, what is the difference between the Unemployed and educated female labor force (% of population) in Hungary and Unemployed and educated female labor force (% of population) in San Marino?
Offer a terse response. -17. In the year 2004, what is the difference between the Unemployed and educated female labor force (% of population) of Israel and Unemployed and educated female labor force (% of population) of San Marino?
Offer a very short reply. 1.4. What is the ratio of the Unemployed and educated female labor force (% of population) of North America in 1996 to that in 1997?
Your answer should be compact. 1.03. What is the ratio of the Unemployed and educated female labor force (% of population) of Hungary in 1996 to that in 1997?
Offer a terse response. 1.29. What is the ratio of the Unemployed and educated female labor force (% of population) in Israel in 1996 to that in 1997?
Provide a short and direct response. 1.03. What is the ratio of the Unemployed and educated female labor force (% of population) of San Marino in 1996 to that in 1997?
Provide a succinct answer. 0.86. What is the ratio of the Unemployed and educated female labor force (% of population) of North America in 1996 to that in 1998?
Keep it short and to the point. 1.06. What is the ratio of the Unemployed and educated female labor force (% of population) of Hungary in 1996 to that in 1998?
Provide a succinct answer. 1.42. What is the ratio of the Unemployed and educated female labor force (% of population) of Israel in 1996 to that in 1998?
Keep it short and to the point. 0.93. What is the ratio of the Unemployed and educated female labor force (% of population) of San Marino in 1996 to that in 1998?
Your answer should be compact. 0.91. What is the ratio of the Unemployed and educated female labor force (% of population) in North America in 1996 to that in 1999?
Ensure brevity in your answer.  1.03. What is the ratio of the Unemployed and educated female labor force (% of population) in Hungary in 1996 to that in 1999?
Your answer should be compact. 1.74. What is the ratio of the Unemployed and educated female labor force (% of population) in Israel in 1996 to that in 1999?
Your answer should be compact. 0.93. What is the ratio of the Unemployed and educated female labor force (% of population) in San Marino in 1996 to that in 1999?
Provide a short and direct response. 0.88. What is the ratio of the Unemployed and educated female labor force (% of population) in North America in 1996 to that in 2001?
Offer a terse response. 0.95. What is the ratio of the Unemployed and educated female labor force (% of population) in Hungary in 1996 to that in 2001?
Provide a short and direct response. 1.06. What is the ratio of the Unemployed and educated female labor force (% of population) in Israel in 1996 to that in 2001?
Your response must be concise. 1.24. What is the ratio of the Unemployed and educated female labor force (% of population) of San Marino in 1996 to that in 2001?
Your answer should be very brief. 2.79. What is the ratio of the Unemployed and educated female labor force (% of population) of North America in 1996 to that in 2002?
Your answer should be very brief. 0.9. What is the ratio of the Unemployed and educated female labor force (% of population) of Hungary in 1996 to that in 2002?
Make the answer very short. 0.66. What is the ratio of the Unemployed and educated female labor force (% of population) of Israel in 1996 to that in 2002?
Provide a succinct answer. 1.15. What is the ratio of the Unemployed and educated female labor force (% of population) in San Marino in 1996 to that in 2002?
Offer a terse response. 2.69. What is the ratio of the Unemployed and educated female labor force (% of population) of North America in 1996 to that in 2003?
Your answer should be compact. 0.89. What is the ratio of the Unemployed and educated female labor force (% of population) of Hungary in 1996 to that in 2003?
Your response must be concise. 1.02. What is the ratio of the Unemployed and educated female labor force (% of population) in Israel in 1996 to that in 2003?
Your answer should be compact. 1.14. What is the ratio of the Unemployed and educated female labor force (% of population) in San Marino in 1996 to that in 2003?
Provide a short and direct response. 2.55. What is the ratio of the Unemployed and educated female labor force (% of population) of North America in 1996 to that in 2004?
Provide a succinct answer. 0.89. What is the ratio of the Unemployed and educated female labor force (% of population) of Hungary in 1996 to that in 2004?
Offer a terse response. 0.5. What is the ratio of the Unemployed and educated female labor force (% of population) in Israel in 1996 to that in 2004?
Offer a terse response. 1.21. What is the ratio of the Unemployed and educated female labor force (% of population) in San Marino in 1996 to that in 2004?
Keep it short and to the point. 2.03. What is the ratio of the Unemployed and educated female labor force (% of population) of North America in 1997 to that in 1998?
Your answer should be compact. 1.03. What is the ratio of the Unemployed and educated female labor force (% of population) of Hungary in 1997 to that in 1998?
Make the answer very short. 1.11. What is the ratio of the Unemployed and educated female labor force (% of population) of Israel in 1997 to that in 1998?
Provide a short and direct response. 0.9. What is the ratio of the Unemployed and educated female labor force (% of population) in San Marino in 1997 to that in 1998?
Provide a short and direct response. 1.06. What is the ratio of the Unemployed and educated female labor force (% of population) of North America in 1997 to that in 1999?
Give a very brief answer. 1. What is the ratio of the Unemployed and educated female labor force (% of population) of Hungary in 1997 to that in 1999?
Offer a very short reply. 1.35. What is the ratio of the Unemployed and educated female labor force (% of population) in Israel in 1997 to that in 1999?
Give a very brief answer. 0.9. What is the ratio of the Unemployed and educated female labor force (% of population) in San Marino in 1997 to that in 1999?
Make the answer very short. 1.02. What is the ratio of the Unemployed and educated female labor force (% of population) in North America in 1997 to that in 2001?
Provide a short and direct response. 0.92. What is the ratio of the Unemployed and educated female labor force (% of population) in Hungary in 1997 to that in 2001?
Make the answer very short. 0.82. What is the ratio of the Unemployed and educated female labor force (% of population) in Israel in 1997 to that in 2001?
Give a very brief answer. 1.21. What is the ratio of the Unemployed and educated female labor force (% of population) in San Marino in 1997 to that in 2001?
Provide a succinct answer. 3.24. What is the ratio of the Unemployed and educated female labor force (% of population) of North America in 1997 to that in 2002?
Your response must be concise. 0.88. What is the ratio of the Unemployed and educated female labor force (% of population) of Hungary in 1997 to that in 2002?
Your answer should be compact. 0.51. What is the ratio of the Unemployed and educated female labor force (% of population) in Israel in 1997 to that in 2002?
Keep it short and to the point. 1.12. What is the ratio of the Unemployed and educated female labor force (% of population) of San Marino in 1997 to that in 2002?
Your answer should be very brief. 3.12. What is the ratio of the Unemployed and educated female labor force (% of population) in North America in 1997 to that in 2003?
Provide a short and direct response. 0.86. What is the ratio of the Unemployed and educated female labor force (% of population) of Hungary in 1997 to that in 2003?
Your answer should be very brief. 0.79. What is the ratio of the Unemployed and educated female labor force (% of population) in Israel in 1997 to that in 2003?
Provide a succinct answer. 1.11. What is the ratio of the Unemployed and educated female labor force (% of population) in San Marino in 1997 to that in 2003?
Make the answer very short. 2.96. What is the ratio of the Unemployed and educated female labor force (% of population) in North America in 1997 to that in 2004?
Offer a terse response. 0.86. What is the ratio of the Unemployed and educated female labor force (% of population) in Hungary in 1997 to that in 2004?
Provide a succinct answer. 0.39. What is the ratio of the Unemployed and educated female labor force (% of population) in Israel in 1997 to that in 2004?
Keep it short and to the point. 1.18. What is the ratio of the Unemployed and educated female labor force (% of population) in San Marino in 1997 to that in 2004?
Make the answer very short. 2.36. What is the ratio of the Unemployed and educated female labor force (% of population) of North America in 1998 to that in 1999?
Provide a succinct answer. 0.97. What is the ratio of the Unemployed and educated female labor force (% of population) in Hungary in 1998 to that in 1999?
Your answer should be very brief. 1.23. What is the ratio of the Unemployed and educated female labor force (% of population) of Israel in 1998 to that in 1999?
Keep it short and to the point. 1. What is the ratio of the Unemployed and educated female labor force (% of population) in San Marino in 1998 to that in 1999?
Your response must be concise. 0.96. What is the ratio of the Unemployed and educated female labor force (% of population) in North America in 1998 to that in 2001?
Provide a succinct answer. 0.89. What is the ratio of the Unemployed and educated female labor force (% of population) in Hungary in 1998 to that in 2001?
Your answer should be very brief. 0.75. What is the ratio of the Unemployed and educated female labor force (% of population) in Israel in 1998 to that in 2001?
Provide a succinct answer. 1.33. What is the ratio of the Unemployed and educated female labor force (% of population) in San Marino in 1998 to that in 2001?
Your answer should be very brief. 3.05. What is the ratio of the Unemployed and educated female labor force (% of population) of North America in 1998 to that in 2002?
Keep it short and to the point. 0.85. What is the ratio of the Unemployed and educated female labor force (% of population) of Hungary in 1998 to that in 2002?
Your response must be concise. 0.46. What is the ratio of the Unemployed and educated female labor force (% of population) of Israel in 1998 to that in 2002?
Give a very brief answer. 1.24. What is the ratio of the Unemployed and educated female labor force (% of population) of San Marino in 1998 to that in 2002?
Your response must be concise. 2.94. What is the ratio of the Unemployed and educated female labor force (% of population) in North America in 1998 to that in 2003?
Make the answer very short. 0.84. What is the ratio of the Unemployed and educated female labor force (% of population) in Hungary in 1998 to that in 2003?
Offer a very short reply. 0.72. What is the ratio of the Unemployed and educated female labor force (% of population) of Israel in 1998 to that in 2003?
Offer a very short reply. 1.23. What is the ratio of the Unemployed and educated female labor force (% of population) of San Marino in 1998 to that in 2003?
Provide a succinct answer. 2.79. What is the ratio of the Unemployed and educated female labor force (% of population) of North America in 1998 to that in 2004?
Give a very brief answer. 0.83. What is the ratio of the Unemployed and educated female labor force (% of population) of Hungary in 1998 to that in 2004?
Your response must be concise. 0.35. What is the ratio of the Unemployed and educated female labor force (% of population) in Israel in 1998 to that in 2004?
Your response must be concise. 1.31. What is the ratio of the Unemployed and educated female labor force (% of population) in San Marino in 1998 to that in 2004?
Your response must be concise. 2.22. What is the ratio of the Unemployed and educated female labor force (% of population) of North America in 1999 to that in 2001?
Keep it short and to the point. 0.92. What is the ratio of the Unemployed and educated female labor force (% of population) in Hungary in 1999 to that in 2001?
Offer a terse response. 0.61. What is the ratio of the Unemployed and educated female labor force (% of population) of Israel in 1999 to that in 2001?
Make the answer very short. 1.33. What is the ratio of the Unemployed and educated female labor force (% of population) in San Marino in 1999 to that in 2001?
Make the answer very short. 3.18. What is the ratio of the Unemployed and educated female labor force (% of population) of North America in 1999 to that in 2002?
Offer a terse response. 0.88. What is the ratio of the Unemployed and educated female labor force (% of population) in Hungary in 1999 to that in 2002?
Ensure brevity in your answer.  0.38. What is the ratio of the Unemployed and educated female labor force (% of population) of Israel in 1999 to that in 2002?
Offer a very short reply. 1.24. What is the ratio of the Unemployed and educated female labor force (% of population) in San Marino in 1999 to that in 2002?
Provide a succinct answer. 3.06. What is the ratio of the Unemployed and educated female labor force (% of population) of North America in 1999 to that in 2003?
Your response must be concise. 0.86. What is the ratio of the Unemployed and educated female labor force (% of population) of Hungary in 1999 to that in 2003?
Ensure brevity in your answer.  0.58. What is the ratio of the Unemployed and educated female labor force (% of population) in Israel in 1999 to that in 2003?
Offer a very short reply. 1.23. What is the ratio of the Unemployed and educated female labor force (% of population) of San Marino in 1999 to that in 2003?
Provide a succinct answer. 2.91. What is the ratio of the Unemployed and educated female labor force (% of population) in North America in 1999 to that in 2004?
Your answer should be compact. 0.86. What is the ratio of the Unemployed and educated female labor force (% of population) in Hungary in 1999 to that in 2004?
Your answer should be very brief. 0.28. What is the ratio of the Unemployed and educated female labor force (% of population) of Israel in 1999 to that in 2004?
Ensure brevity in your answer.  1.31. What is the ratio of the Unemployed and educated female labor force (% of population) of San Marino in 1999 to that in 2004?
Provide a short and direct response. 2.32. What is the ratio of the Unemployed and educated female labor force (% of population) of North America in 2001 to that in 2002?
Make the answer very short. 0.96. What is the ratio of the Unemployed and educated female labor force (% of population) in Hungary in 2001 to that in 2002?
Your answer should be compact. 0.62. What is the ratio of the Unemployed and educated female labor force (% of population) in Israel in 2001 to that in 2002?
Give a very brief answer. 0.93. What is the ratio of the Unemployed and educated female labor force (% of population) in San Marino in 2001 to that in 2002?
Make the answer very short. 0.96. What is the ratio of the Unemployed and educated female labor force (% of population) in North America in 2001 to that in 2003?
Give a very brief answer. 0.94. What is the ratio of the Unemployed and educated female labor force (% of population) of Hungary in 2001 to that in 2003?
Make the answer very short. 0.96. What is the ratio of the Unemployed and educated female labor force (% of population) in Israel in 2001 to that in 2003?
Your answer should be compact. 0.92. What is the ratio of the Unemployed and educated female labor force (% of population) of San Marino in 2001 to that in 2003?
Keep it short and to the point. 0.91. What is the ratio of the Unemployed and educated female labor force (% of population) of North America in 2001 to that in 2004?
Your response must be concise. 0.94. What is the ratio of the Unemployed and educated female labor force (% of population) of Hungary in 2001 to that in 2004?
Make the answer very short. 0.47. What is the ratio of the Unemployed and educated female labor force (% of population) in Israel in 2001 to that in 2004?
Provide a succinct answer. 0.98. What is the ratio of the Unemployed and educated female labor force (% of population) of San Marino in 2001 to that in 2004?
Make the answer very short. 0.73. What is the ratio of the Unemployed and educated female labor force (% of population) in North America in 2002 to that in 2003?
Provide a succinct answer. 0.98. What is the ratio of the Unemployed and educated female labor force (% of population) of Hungary in 2002 to that in 2003?
Provide a succinct answer. 1.55. What is the ratio of the Unemployed and educated female labor force (% of population) of San Marino in 2002 to that in 2003?
Make the answer very short. 0.95. What is the ratio of the Unemployed and educated female labor force (% of population) of Hungary in 2002 to that in 2004?
Your response must be concise. 0.75. What is the ratio of the Unemployed and educated female labor force (% of population) of Israel in 2002 to that in 2004?
Offer a terse response. 1.05. What is the ratio of the Unemployed and educated female labor force (% of population) of San Marino in 2002 to that in 2004?
Offer a terse response. 0.76. What is the ratio of the Unemployed and educated female labor force (% of population) in North America in 2003 to that in 2004?
Provide a short and direct response. 1. What is the ratio of the Unemployed and educated female labor force (% of population) of Hungary in 2003 to that in 2004?
Provide a short and direct response. 0.49. What is the ratio of the Unemployed and educated female labor force (% of population) of Israel in 2003 to that in 2004?
Your response must be concise. 1.06. What is the ratio of the Unemployed and educated female labor force (% of population) of San Marino in 2003 to that in 2004?
Your response must be concise. 0.8. What is the difference between the highest and the second highest Unemployed and educated female labor force (% of population) of North America?
Your answer should be compact. 0.1. What is the difference between the highest and the second highest Unemployed and educated female labor force (% of population) in Israel?
Provide a succinct answer. 0. What is the difference between the highest and the second highest Unemployed and educated female labor force (% of population) of San Marino?
Offer a very short reply. 1.2. What is the difference between the highest and the lowest Unemployed and educated female labor force (% of population) of North America?
Ensure brevity in your answer.  7.74. What is the difference between the highest and the lowest Unemployed and educated female labor force (% of population) in Israel?
Your response must be concise. 9.6. What is the difference between the highest and the lowest Unemployed and educated female labor force (% of population) in San Marino?
Keep it short and to the point. 45.5. 